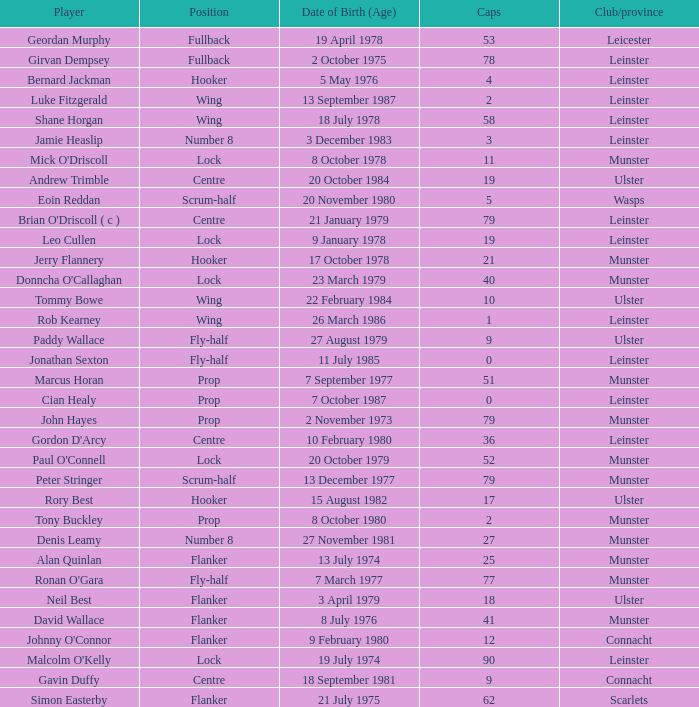What Club/province have caps less than 2 and Jonathan Sexton as player? Leinster. 